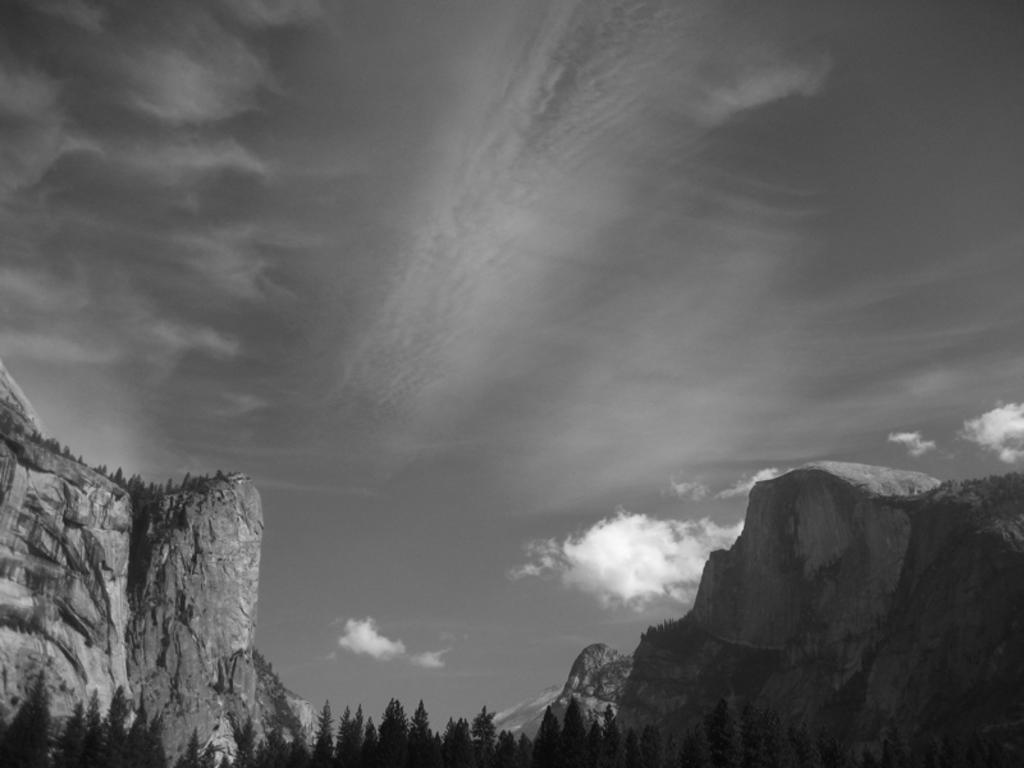What type of vegetation can be seen in the image? There are trees in the image. What is the color scheme of the image? The image is black and white in color. What can be seen in the background of the image? There are clouds and the sky visible in the background of the image. What type of prison is depicted in the image? There is no prison present in the image; it features trees, a black and white color scheme, and clouds in the background. How much oil can be seen in the image? There is no oil present in the image. 